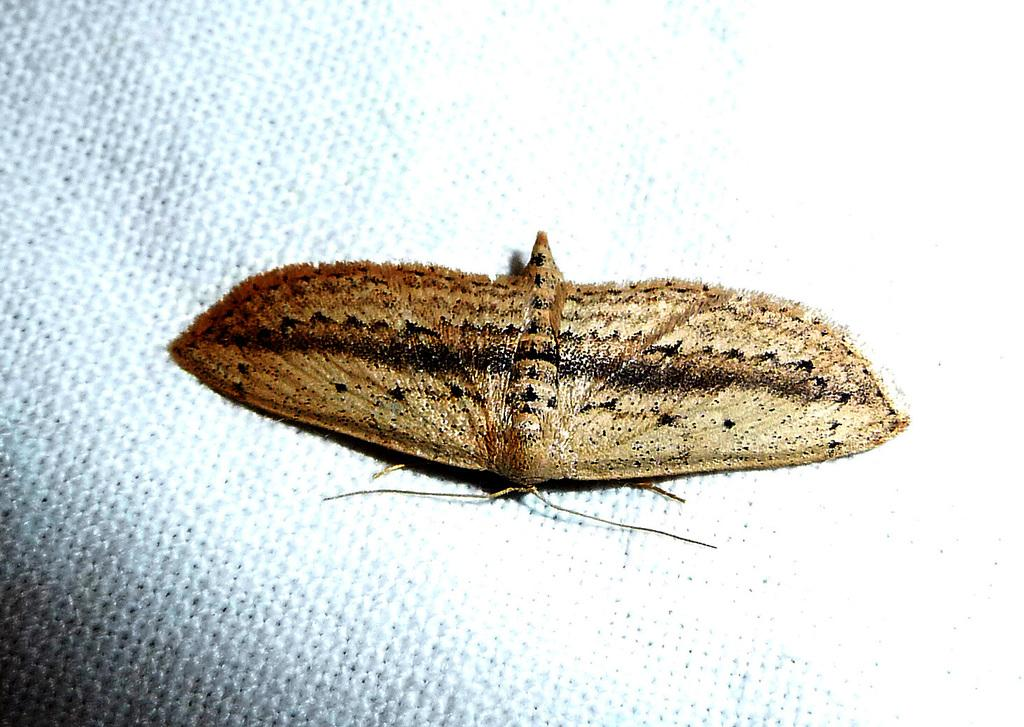What is the main subject of the image? The main subject of the image is a moth. What is the moth resting on in the image? The moth is on the surface of a white color object. Where is the moth and the white color object located in the image? The moth and the white color object are in the center of the image. What type of root can be seen growing from the moth in the image? There is no root growing from the moth in the image, as the moth is a flying insect and not a plant. What game is the moth playing with the white color object in the image? There is no game being played in the image; it simply shows a moth resting on a white color object. 